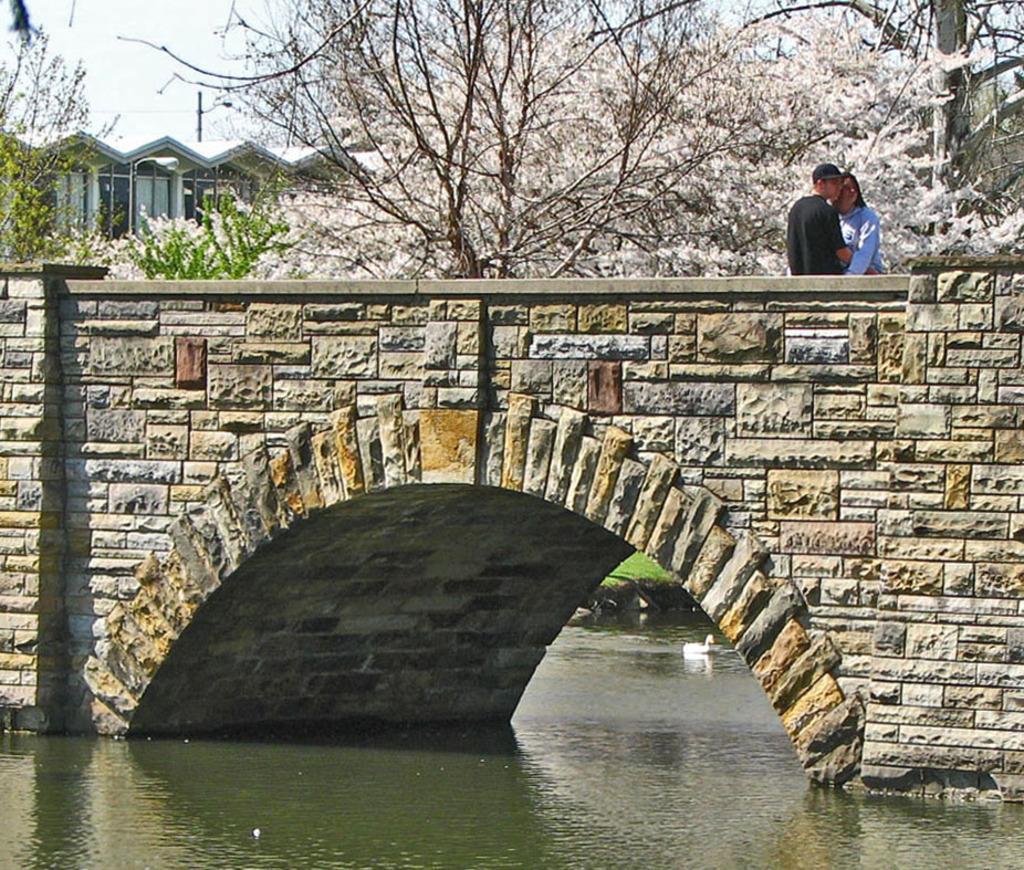How would you summarize this image in a sentence or two? In this image we can see a bird on the water and two persons are on a bridge. In the background we can see trees, building, pole and clouds in the sky. 